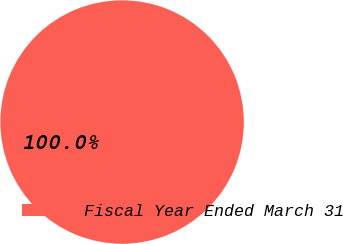Convert chart. <chart><loc_0><loc_0><loc_500><loc_500><pie_chart><fcel>Fiscal Year Ended March 31<nl><fcel>100.0%<nl></chart> 